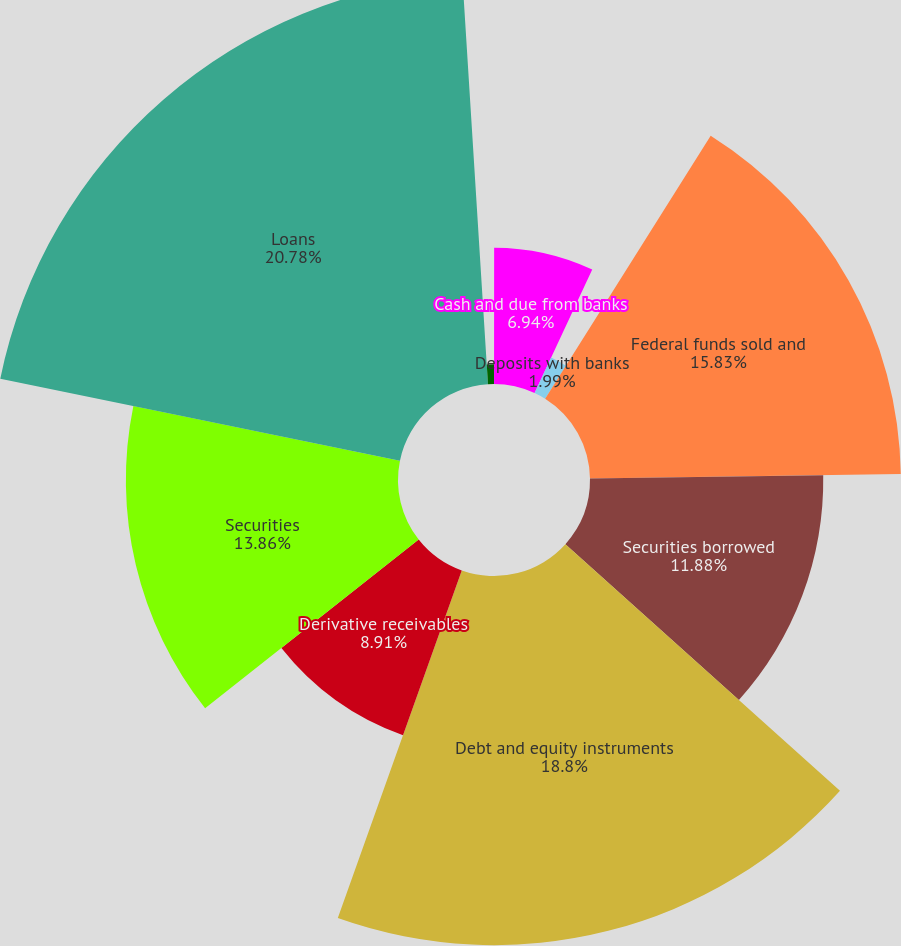Convert chart. <chart><loc_0><loc_0><loc_500><loc_500><pie_chart><fcel>December 31 (in millions)<fcel>Cash and due from banks<fcel>Deposits with banks<fcel>Federal funds sold and<fcel>Securities borrowed<fcel>Debt and equity instruments<fcel>Derivative receivables<fcel>Securities<fcel>Loans<fcel>Allowance for loan losses<nl><fcel>0.01%<fcel>6.94%<fcel>1.99%<fcel>15.83%<fcel>11.88%<fcel>18.8%<fcel>8.91%<fcel>13.86%<fcel>20.78%<fcel>1.0%<nl></chart> 